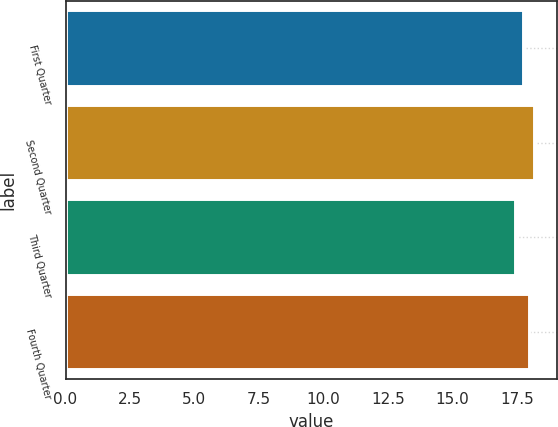<chart> <loc_0><loc_0><loc_500><loc_500><bar_chart><fcel>First Quarter<fcel>Second Quarter<fcel>Third Quarter<fcel>Fourth Quarter<nl><fcel>17.75<fcel>18.15<fcel>17.44<fcel>17.97<nl></chart> 